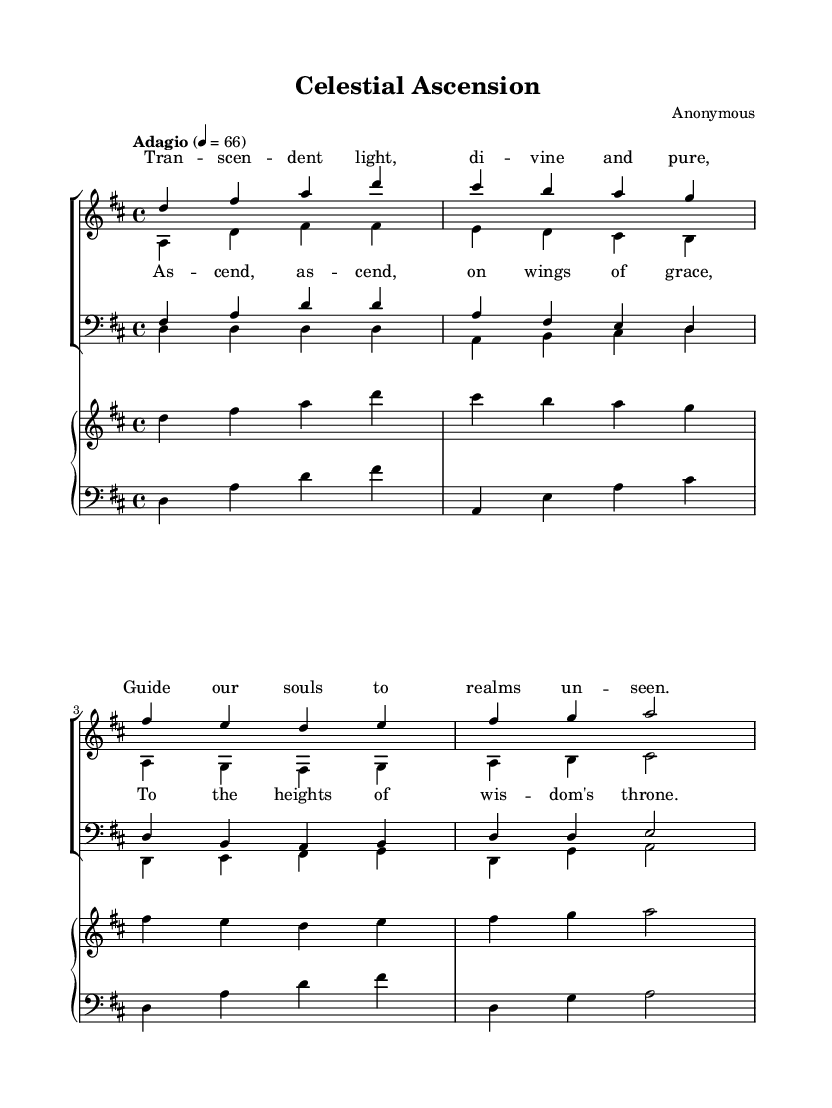What is the key signature of this music? The key signature indicated at the beginning of the score shows two sharps, which corresponds to D major.
Answer: D major What is the time signature of this music? The time signature displayed at the beginning of the score is 4/4, indicating that there are four beats per measure.
Answer: 4/4 What is the tempo marking of this piece? The tempo marking in the score is "Adagio," which suggests a slow and leisurely pace of 66 beats per minute.
Answer: Adagio How many voices are present in the choir arrangement? The score shows two staffs for women's voices and two for men's voices, indicating there are a total of four distinct voices: sopranos, altos, tenors, and basses.
Answer: Four What is the lyrical theme of the verse? The verse contains lyrics that mention transcendent light and guidance for the soul, reflecting a spiritual and uplifting theme.
Answer: Transcendent light, guidance for the soul Which musical part has the highest pitch? In the score, the soprano part is written in a higher octave than the other voices, making it the highest pitch in the arrangement.
Answer: Soprano 